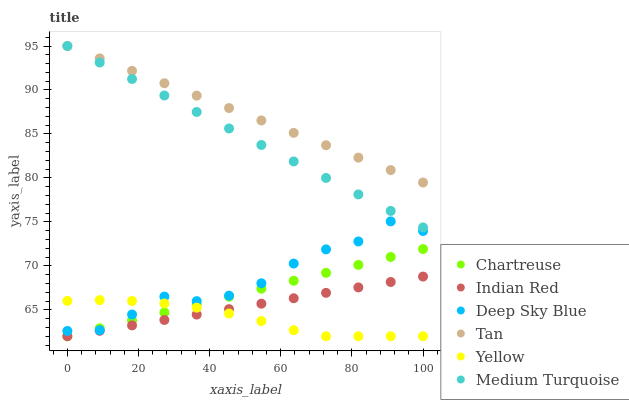Does Yellow have the minimum area under the curve?
Answer yes or no. Yes. Does Tan have the maximum area under the curve?
Answer yes or no. Yes. Does Indian Red have the minimum area under the curve?
Answer yes or no. No. Does Indian Red have the maximum area under the curve?
Answer yes or no. No. Is Indian Red the smoothest?
Answer yes or no. Yes. Is Deep Sky Blue the roughest?
Answer yes or no. Yes. Is Yellow the smoothest?
Answer yes or no. No. Is Yellow the roughest?
Answer yes or no. No. Does Indian Red have the lowest value?
Answer yes or no. Yes. Does Deep Sky Blue have the lowest value?
Answer yes or no. No. Does Tan have the highest value?
Answer yes or no. Yes. Does Indian Red have the highest value?
Answer yes or no. No. Is Yellow less than Tan?
Answer yes or no. Yes. Is Medium Turquoise greater than Chartreuse?
Answer yes or no. Yes. Does Yellow intersect Chartreuse?
Answer yes or no. Yes. Is Yellow less than Chartreuse?
Answer yes or no. No. Is Yellow greater than Chartreuse?
Answer yes or no. No. Does Yellow intersect Tan?
Answer yes or no. No. 